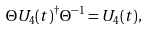<formula> <loc_0><loc_0><loc_500><loc_500>\Theta U _ { 4 } ( t ) ^ { \dagger } \Theta ^ { - 1 } = U _ { 4 } ( t ) ,</formula> 